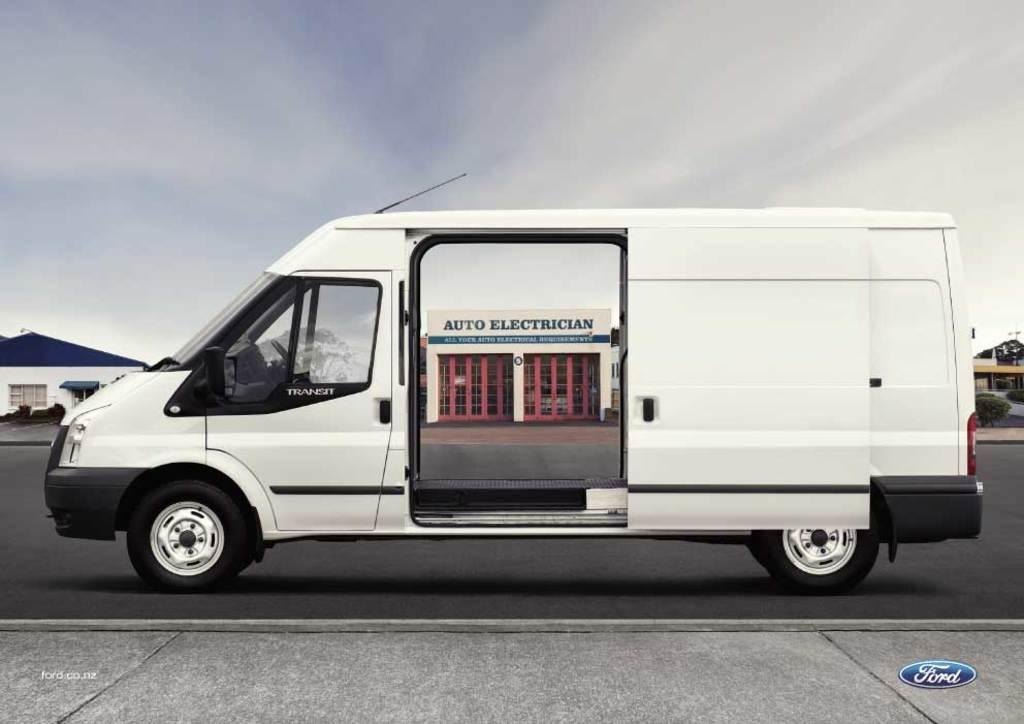<image>
Summarize the visual content of the image. A white van with open doors displays an Auto Electrician store behind it 